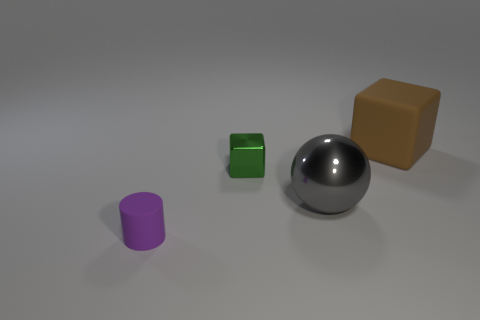How many things are green shiny blocks or yellow objects?
Your answer should be very brief. 1. What number of other objects are there of the same shape as the small rubber thing?
Provide a short and direct response. 0. Do the object left of the green cube and the tiny thing on the right side of the tiny purple cylinder have the same material?
Give a very brief answer. No. What is the shape of the object that is right of the metal cube and in front of the large brown matte block?
Provide a succinct answer. Sphere. There is a thing that is to the left of the gray metal ball and on the right side of the matte cylinder; what material is it?
Offer a very short reply. Metal. What shape is the gray thing that is the same material as the green cube?
Offer a very short reply. Sphere. Are there any other things of the same color as the large shiny object?
Give a very brief answer. No. Are there more big brown objects on the right side of the tiny metallic object than big yellow rubber objects?
Keep it short and to the point. Yes. What is the small purple object made of?
Ensure brevity in your answer.  Rubber. How many other cylinders are the same size as the purple matte cylinder?
Keep it short and to the point. 0. 